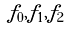Convert formula to latex. <formula><loc_0><loc_0><loc_500><loc_500>f _ { 0 } , f _ { 1 } , f _ { 2 }</formula> 